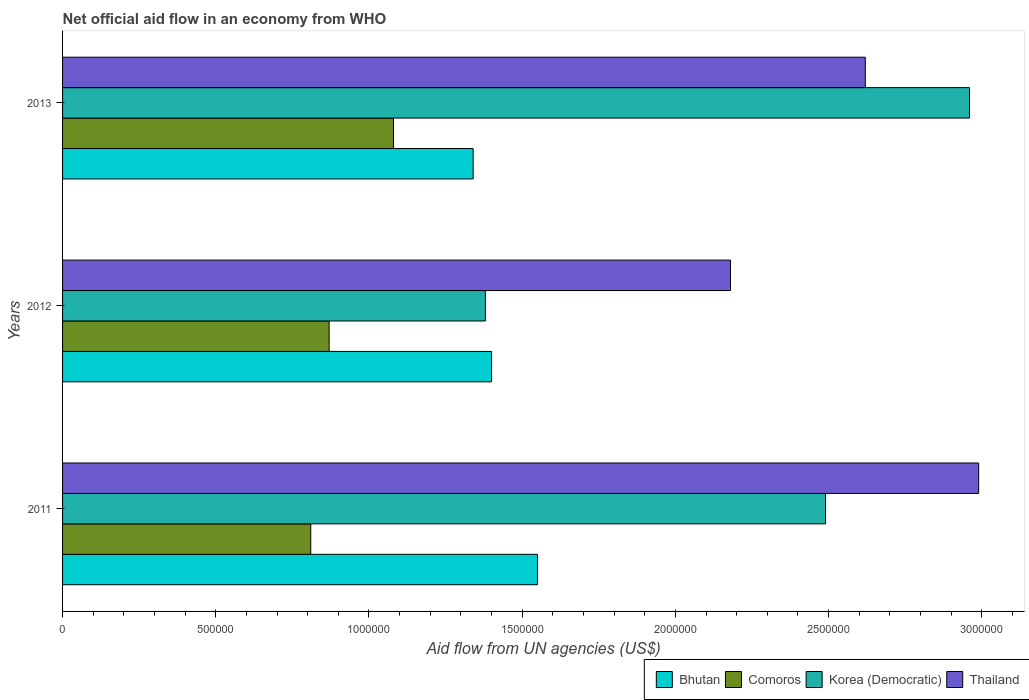How many different coloured bars are there?
Make the answer very short. 4. Are the number of bars per tick equal to the number of legend labels?
Your response must be concise. Yes. Are the number of bars on each tick of the Y-axis equal?
Offer a very short reply. Yes. How many bars are there on the 2nd tick from the top?
Keep it short and to the point. 4. What is the label of the 2nd group of bars from the top?
Make the answer very short. 2012. What is the net official aid flow in Comoros in 2013?
Keep it short and to the point. 1.08e+06. Across all years, what is the maximum net official aid flow in Thailand?
Give a very brief answer. 2.99e+06. Across all years, what is the minimum net official aid flow in Korea (Democratic)?
Provide a short and direct response. 1.38e+06. In which year was the net official aid flow in Thailand maximum?
Your response must be concise. 2011. In which year was the net official aid flow in Thailand minimum?
Offer a very short reply. 2012. What is the total net official aid flow in Comoros in the graph?
Your answer should be very brief. 2.76e+06. What is the difference between the net official aid flow in Bhutan in 2012 and that in 2013?
Make the answer very short. 6.00e+04. What is the difference between the net official aid flow in Comoros in 2011 and the net official aid flow in Thailand in 2013?
Make the answer very short. -1.81e+06. What is the average net official aid flow in Thailand per year?
Ensure brevity in your answer.  2.60e+06. In the year 2012, what is the difference between the net official aid flow in Thailand and net official aid flow in Bhutan?
Your answer should be compact. 7.80e+05. What is the ratio of the net official aid flow in Comoros in 2012 to that in 2013?
Your response must be concise. 0.81. Is the net official aid flow in Bhutan in 2012 less than that in 2013?
Make the answer very short. No. What is the difference between the highest and the lowest net official aid flow in Bhutan?
Offer a very short reply. 2.10e+05. In how many years, is the net official aid flow in Bhutan greater than the average net official aid flow in Bhutan taken over all years?
Offer a very short reply. 1. What does the 4th bar from the top in 2013 represents?
Your response must be concise. Bhutan. What does the 2nd bar from the bottom in 2013 represents?
Offer a terse response. Comoros. Is it the case that in every year, the sum of the net official aid flow in Thailand and net official aid flow in Comoros is greater than the net official aid flow in Bhutan?
Provide a short and direct response. Yes. How many bars are there?
Make the answer very short. 12. How many years are there in the graph?
Make the answer very short. 3. What is the title of the graph?
Offer a very short reply. Net official aid flow in an economy from WHO. Does "Luxembourg" appear as one of the legend labels in the graph?
Give a very brief answer. No. What is the label or title of the X-axis?
Your answer should be very brief. Aid flow from UN agencies (US$). What is the label or title of the Y-axis?
Ensure brevity in your answer.  Years. What is the Aid flow from UN agencies (US$) in Bhutan in 2011?
Keep it short and to the point. 1.55e+06. What is the Aid flow from UN agencies (US$) of Comoros in 2011?
Provide a succinct answer. 8.10e+05. What is the Aid flow from UN agencies (US$) of Korea (Democratic) in 2011?
Your answer should be compact. 2.49e+06. What is the Aid flow from UN agencies (US$) in Thailand in 2011?
Your response must be concise. 2.99e+06. What is the Aid flow from UN agencies (US$) of Bhutan in 2012?
Offer a very short reply. 1.40e+06. What is the Aid flow from UN agencies (US$) of Comoros in 2012?
Provide a succinct answer. 8.70e+05. What is the Aid flow from UN agencies (US$) in Korea (Democratic) in 2012?
Offer a very short reply. 1.38e+06. What is the Aid flow from UN agencies (US$) of Thailand in 2012?
Provide a short and direct response. 2.18e+06. What is the Aid flow from UN agencies (US$) of Bhutan in 2013?
Provide a succinct answer. 1.34e+06. What is the Aid flow from UN agencies (US$) in Comoros in 2013?
Your response must be concise. 1.08e+06. What is the Aid flow from UN agencies (US$) in Korea (Democratic) in 2013?
Your answer should be compact. 2.96e+06. What is the Aid flow from UN agencies (US$) in Thailand in 2013?
Provide a short and direct response. 2.62e+06. Across all years, what is the maximum Aid flow from UN agencies (US$) in Bhutan?
Your answer should be very brief. 1.55e+06. Across all years, what is the maximum Aid flow from UN agencies (US$) of Comoros?
Give a very brief answer. 1.08e+06. Across all years, what is the maximum Aid flow from UN agencies (US$) in Korea (Democratic)?
Keep it short and to the point. 2.96e+06. Across all years, what is the maximum Aid flow from UN agencies (US$) of Thailand?
Keep it short and to the point. 2.99e+06. Across all years, what is the minimum Aid flow from UN agencies (US$) of Bhutan?
Make the answer very short. 1.34e+06. Across all years, what is the minimum Aid flow from UN agencies (US$) in Comoros?
Provide a short and direct response. 8.10e+05. Across all years, what is the minimum Aid flow from UN agencies (US$) of Korea (Democratic)?
Your response must be concise. 1.38e+06. Across all years, what is the minimum Aid flow from UN agencies (US$) of Thailand?
Provide a short and direct response. 2.18e+06. What is the total Aid flow from UN agencies (US$) of Bhutan in the graph?
Make the answer very short. 4.29e+06. What is the total Aid flow from UN agencies (US$) of Comoros in the graph?
Provide a succinct answer. 2.76e+06. What is the total Aid flow from UN agencies (US$) in Korea (Democratic) in the graph?
Ensure brevity in your answer.  6.83e+06. What is the total Aid flow from UN agencies (US$) of Thailand in the graph?
Keep it short and to the point. 7.79e+06. What is the difference between the Aid flow from UN agencies (US$) in Bhutan in 2011 and that in 2012?
Offer a terse response. 1.50e+05. What is the difference between the Aid flow from UN agencies (US$) of Comoros in 2011 and that in 2012?
Your response must be concise. -6.00e+04. What is the difference between the Aid flow from UN agencies (US$) in Korea (Democratic) in 2011 and that in 2012?
Make the answer very short. 1.11e+06. What is the difference between the Aid flow from UN agencies (US$) in Thailand in 2011 and that in 2012?
Provide a succinct answer. 8.10e+05. What is the difference between the Aid flow from UN agencies (US$) of Bhutan in 2011 and that in 2013?
Provide a short and direct response. 2.10e+05. What is the difference between the Aid flow from UN agencies (US$) of Korea (Democratic) in 2011 and that in 2013?
Your answer should be very brief. -4.70e+05. What is the difference between the Aid flow from UN agencies (US$) of Thailand in 2011 and that in 2013?
Make the answer very short. 3.70e+05. What is the difference between the Aid flow from UN agencies (US$) in Korea (Democratic) in 2012 and that in 2013?
Offer a very short reply. -1.58e+06. What is the difference between the Aid flow from UN agencies (US$) of Thailand in 2012 and that in 2013?
Make the answer very short. -4.40e+05. What is the difference between the Aid flow from UN agencies (US$) in Bhutan in 2011 and the Aid flow from UN agencies (US$) in Comoros in 2012?
Provide a succinct answer. 6.80e+05. What is the difference between the Aid flow from UN agencies (US$) of Bhutan in 2011 and the Aid flow from UN agencies (US$) of Korea (Democratic) in 2012?
Your answer should be compact. 1.70e+05. What is the difference between the Aid flow from UN agencies (US$) of Bhutan in 2011 and the Aid flow from UN agencies (US$) of Thailand in 2012?
Keep it short and to the point. -6.30e+05. What is the difference between the Aid flow from UN agencies (US$) in Comoros in 2011 and the Aid flow from UN agencies (US$) in Korea (Democratic) in 2012?
Your answer should be very brief. -5.70e+05. What is the difference between the Aid flow from UN agencies (US$) of Comoros in 2011 and the Aid flow from UN agencies (US$) of Thailand in 2012?
Provide a succinct answer. -1.37e+06. What is the difference between the Aid flow from UN agencies (US$) in Bhutan in 2011 and the Aid flow from UN agencies (US$) in Comoros in 2013?
Provide a short and direct response. 4.70e+05. What is the difference between the Aid flow from UN agencies (US$) of Bhutan in 2011 and the Aid flow from UN agencies (US$) of Korea (Democratic) in 2013?
Provide a short and direct response. -1.41e+06. What is the difference between the Aid flow from UN agencies (US$) of Bhutan in 2011 and the Aid flow from UN agencies (US$) of Thailand in 2013?
Offer a very short reply. -1.07e+06. What is the difference between the Aid flow from UN agencies (US$) in Comoros in 2011 and the Aid flow from UN agencies (US$) in Korea (Democratic) in 2013?
Your response must be concise. -2.15e+06. What is the difference between the Aid flow from UN agencies (US$) in Comoros in 2011 and the Aid flow from UN agencies (US$) in Thailand in 2013?
Provide a short and direct response. -1.81e+06. What is the difference between the Aid flow from UN agencies (US$) of Bhutan in 2012 and the Aid flow from UN agencies (US$) of Comoros in 2013?
Provide a short and direct response. 3.20e+05. What is the difference between the Aid flow from UN agencies (US$) of Bhutan in 2012 and the Aid flow from UN agencies (US$) of Korea (Democratic) in 2013?
Offer a terse response. -1.56e+06. What is the difference between the Aid flow from UN agencies (US$) in Bhutan in 2012 and the Aid flow from UN agencies (US$) in Thailand in 2013?
Provide a succinct answer. -1.22e+06. What is the difference between the Aid flow from UN agencies (US$) in Comoros in 2012 and the Aid flow from UN agencies (US$) in Korea (Democratic) in 2013?
Your answer should be compact. -2.09e+06. What is the difference between the Aid flow from UN agencies (US$) in Comoros in 2012 and the Aid flow from UN agencies (US$) in Thailand in 2013?
Give a very brief answer. -1.75e+06. What is the difference between the Aid flow from UN agencies (US$) of Korea (Democratic) in 2012 and the Aid flow from UN agencies (US$) of Thailand in 2013?
Give a very brief answer. -1.24e+06. What is the average Aid flow from UN agencies (US$) of Bhutan per year?
Your answer should be very brief. 1.43e+06. What is the average Aid flow from UN agencies (US$) in Comoros per year?
Provide a short and direct response. 9.20e+05. What is the average Aid flow from UN agencies (US$) in Korea (Democratic) per year?
Ensure brevity in your answer.  2.28e+06. What is the average Aid flow from UN agencies (US$) in Thailand per year?
Offer a terse response. 2.60e+06. In the year 2011, what is the difference between the Aid flow from UN agencies (US$) in Bhutan and Aid flow from UN agencies (US$) in Comoros?
Provide a succinct answer. 7.40e+05. In the year 2011, what is the difference between the Aid flow from UN agencies (US$) in Bhutan and Aid flow from UN agencies (US$) in Korea (Democratic)?
Offer a terse response. -9.40e+05. In the year 2011, what is the difference between the Aid flow from UN agencies (US$) of Bhutan and Aid flow from UN agencies (US$) of Thailand?
Give a very brief answer. -1.44e+06. In the year 2011, what is the difference between the Aid flow from UN agencies (US$) of Comoros and Aid flow from UN agencies (US$) of Korea (Democratic)?
Your answer should be very brief. -1.68e+06. In the year 2011, what is the difference between the Aid flow from UN agencies (US$) in Comoros and Aid flow from UN agencies (US$) in Thailand?
Ensure brevity in your answer.  -2.18e+06. In the year 2011, what is the difference between the Aid flow from UN agencies (US$) of Korea (Democratic) and Aid flow from UN agencies (US$) of Thailand?
Give a very brief answer. -5.00e+05. In the year 2012, what is the difference between the Aid flow from UN agencies (US$) in Bhutan and Aid flow from UN agencies (US$) in Comoros?
Make the answer very short. 5.30e+05. In the year 2012, what is the difference between the Aid flow from UN agencies (US$) in Bhutan and Aid flow from UN agencies (US$) in Thailand?
Offer a very short reply. -7.80e+05. In the year 2012, what is the difference between the Aid flow from UN agencies (US$) in Comoros and Aid flow from UN agencies (US$) in Korea (Democratic)?
Your answer should be compact. -5.10e+05. In the year 2012, what is the difference between the Aid flow from UN agencies (US$) of Comoros and Aid flow from UN agencies (US$) of Thailand?
Your response must be concise. -1.31e+06. In the year 2012, what is the difference between the Aid flow from UN agencies (US$) of Korea (Democratic) and Aid flow from UN agencies (US$) of Thailand?
Keep it short and to the point. -8.00e+05. In the year 2013, what is the difference between the Aid flow from UN agencies (US$) of Bhutan and Aid flow from UN agencies (US$) of Comoros?
Offer a terse response. 2.60e+05. In the year 2013, what is the difference between the Aid flow from UN agencies (US$) in Bhutan and Aid flow from UN agencies (US$) in Korea (Democratic)?
Provide a succinct answer. -1.62e+06. In the year 2013, what is the difference between the Aid flow from UN agencies (US$) in Bhutan and Aid flow from UN agencies (US$) in Thailand?
Keep it short and to the point. -1.28e+06. In the year 2013, what is the difference between the Aid flow from UN agencies (US$) of Comoros and Aid flow from UN agencies (US$) of Korea (Democratic)?
Ensure brevity in your answer.  -1.88e+06. In the year 2013, what is the difference between the Aid flow from UN agencies (US$) in Comoros and Aid flow from UN agencies (US$) in Thailand?
Your answer should be compact. -1.54e+06. What is the ratio of the Aid flow from UN agencies (US$) of Bhutan in 2011 to that in 2012?
Ensure brevity in your answer.  1.11. What is the ratio of the Aid flow from UN agencies (US$) of Comoros in 2011 to that in 2012?
Keep it short and to the point. 0.93. What is the ratio of the Aid flow from UN agencies (US$) of Korea (Democratic) in 2011 to that in 2012?
Offer a very short reply. 1.8. What is the ratio of the Aid flow from UN agencies (US$) in Thailand in 2011 to that in 2012?
Make the answer very short. 1.37. What is the ratio of the Aid flow from UN agencies (US$) in Bhutan in 2011 to that in 2013?
Ensure brevity in your answer.  1.16. What is the ratio of the Aid flow from UN agencies (US$) in Comoros in 2011 to that in 2013?
Your answer should be very brief. 0.75. What is the ratio of the Aid flow from UN agencies (US$) in Korea (Democratic) in 2011 to that in 2013?
Your answer should be compact. 0.84. What is the ratio of the Aid flow from UN agencies (US$) in Thailand in 2011 to that in 2013?
Ensure brevity in your answer.  1.14. What is the ratio of the Aid flow from UN agencies (US$) in Bhutan in 2012 to that in 2013?
Make the answer very short. 1.04. What is the ratio of the Aid flow from UN agencies (US$) of Comoros in 2012 to that in 2013?
Provide a succinct answer. 0.81. What is the ratio of the Aid flow from UN agencies (US$) in Korea (Democratic) in 2012 to that in 2013?
Make the answer very short. 0.47. What is the ratio of the Aid flow from UN agencies (US$) in Thailand in 2012 to that in 2013?
Ensure brevity in your answer.  0.83. What is the difference between the highest and the second highest Aid flow from UN agencies (US$) of Comoros?
Ensure brevity in your answer.  2.10e+05. What is the difference between the highest and the second highest Aid flow from UN agencies (US$) of Thailand?
Your response must be concise. 3.70e+05. What is the difference between the highest and the lowest Aid flow from UN agencies (US$) of Bhutan?
Your response must be concise. 2.10e+05. What is the difference between the highest and the lowest Aid flow from UN agencies (US$) of Comoros?
Keep it short and to the point. 2.70e+05. What is the difference between the highest and the lowest Aid flow from UN agencies (US$) of Korea (Democratic)?
Ensure brevity in your answer.  1.58e+06. What is the difference between the highest and the lowest Aid flow from UN agencies (US$) of Thailand?
Keep it short and to the point. 8.10e+05. 